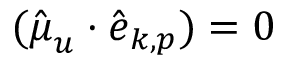<formula> <loc_0><loc_0><loc_500><loc_500>( \hat { \boldsymbol \mu } _ { u } \cdot \hat { \boldsymbol e } _ { { \boldsymbol k } , { p } } ) = 0</formula> 